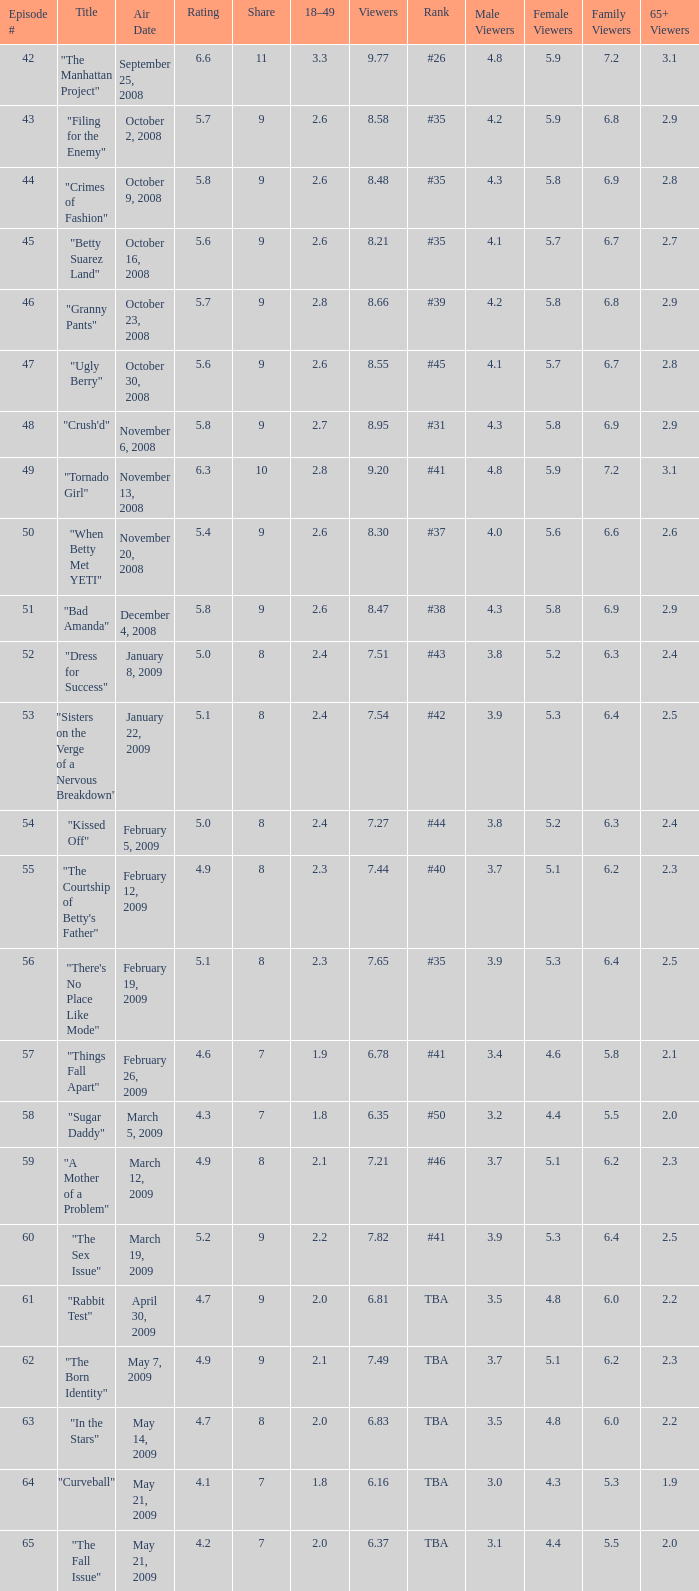What is the total number of Viewers when the rank is #40? 1.0. 